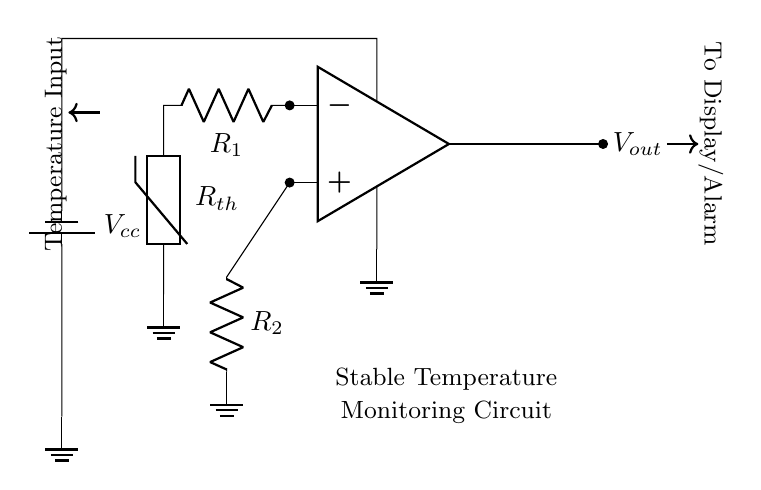What type of sensor is used in this circuit? The circuit uses a thermistor, which is indicated by the label R_th in the diagram. A thermistor is a type of temperature sensor whose resistance changes significantly with temperature.
Answer: Thermistor What is the output voltage denoted as in this circuit? The output voltage is represented as V_out, which is shown as the output of the operational amplifier in the circuit. This voltage will vary based on the temperature input from the thermistor.
Answer: V_out What is the purpose of the resistor labeled R1? R1 is part of the voltage divider circuit with the thermistor. It helps to create an appropriate voltage level that the operational amplifier can process to accurately measure the temperature.
Answer: Limit current How many resistors are present in this circuit? There are two resistors in the circuit: R1 and R2. Both resistors play a role in conditioning the signal from the thermistor before it reaches the operational amplifier.
Answer: Two What role does the operational amplifier play in this circuit? The operational amplifier amplifies the voltage signal that comes from the voltage divider formed by R1 and the thermistor, producing an output voltage that reflects the temperature condition.
Answer: Signal amplification Why is there a battery labeled V_cc in the circuit? The battery V_cc supplies the necessary power to the operational amplifier and other components in the circuit, allowing it to function and provide output based on the input temperature signal.
Answer: Power supply What happens to V_out when the temperature increases? As temperature increases, the resistance of the thermistor decreases, which changes the voltage at the input of the operational amplifier, leading to an increase in V_out according to the amplifier's gain configuration.
Answer: V_out increases 